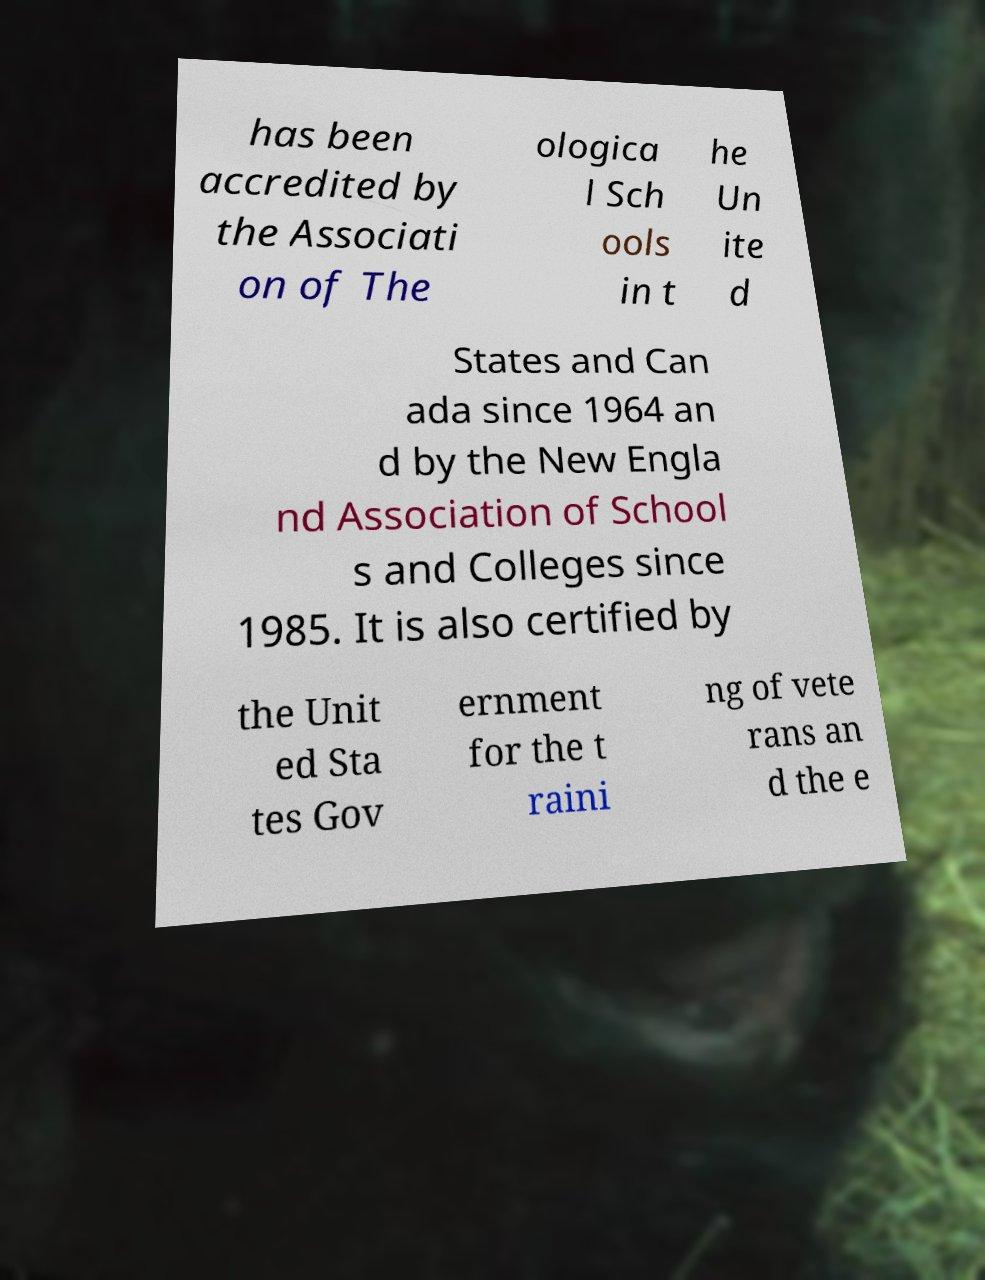I need the written content from this picture converted into text. Can you do that? has been accredited by the Associati on of The ologica l Sch ools in t he Un ite d States and Can ada since 1964 an d by the New Engla nd Association of School s and Colleges since 1985. It is also certified by the Unit ed Sta tes Gov ernment for the t raini ng of vete rans an d the e 